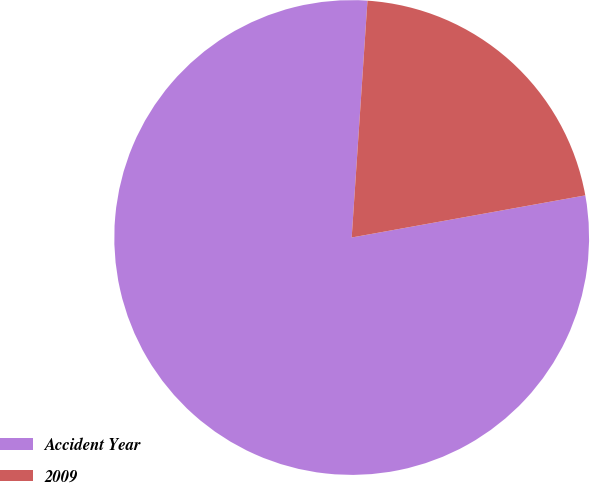Convert chart. <chart><loc_0><loc_0><loc_500><loc_500><pie_chart><fcel>Accident Year<fcel>2009<nl><fcel>78.9%<fcel>21.1%<nl></chart> 